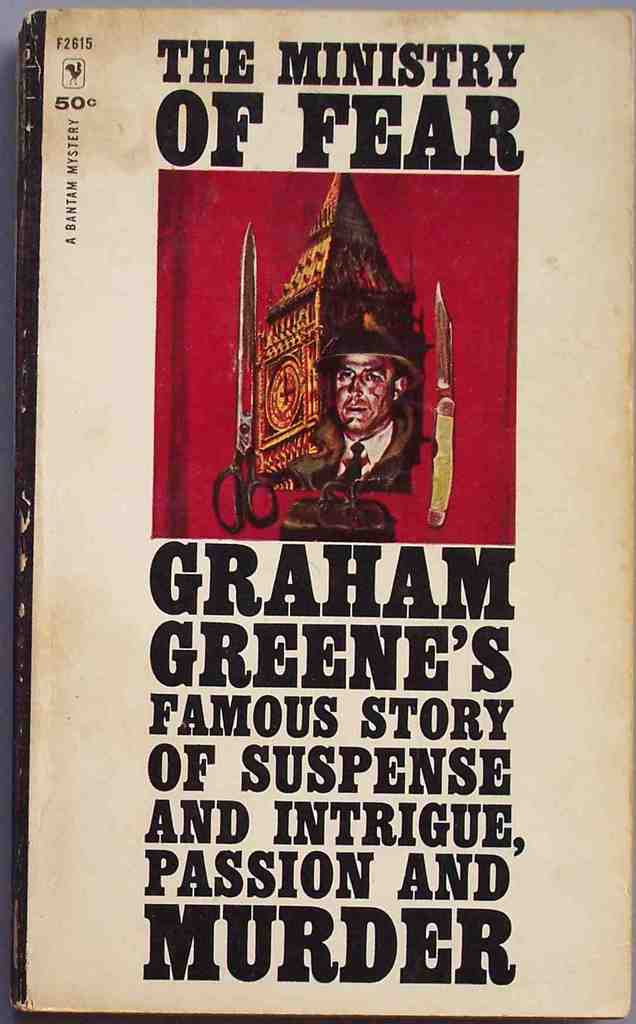Can you describe the emotional impact the cover might have on a potential reader? The cover of 'The Ministry of Fear', with its stark imagery and bold typography, likely instills a feeling of anticipation and intrigue. The mysterious depiction of the man and the ominous color palette might stir a sense of curiosity and unease, compelling the viewer to delve into the book to uncover the layers of suspense and mystery promised by the visual and textual hints. 